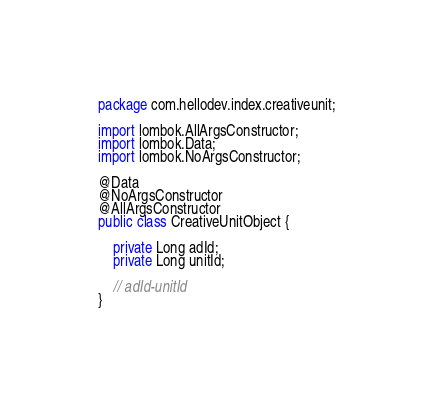Convert code to text. <code><loc_0><loc_0><loc_500><loc_500><_Java_>package com.hellodev.index.creativeunit;

import lombok.AllArgsConstructor;
import lombok.Data;
import lombok.NoArgsConstructor;

@Data
@NoArgsConstructor
@AllArgsConstructor
public class CreativeUnitObject {

    private Long adId;
    private Long unitId;

    // adId-unitId
}
</code> 